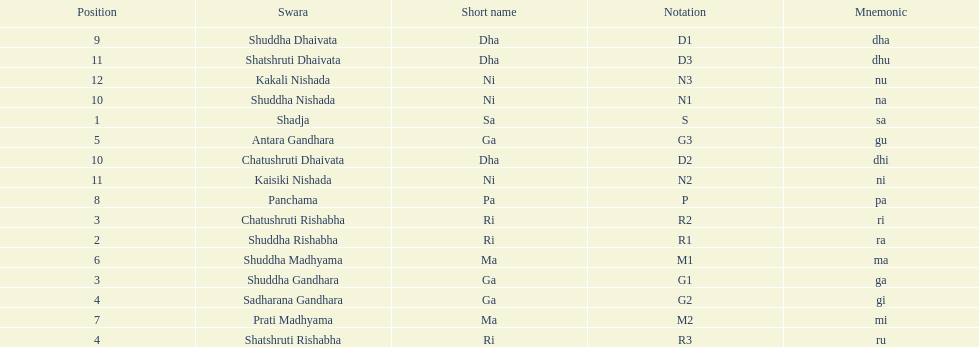What is the name of the swara that comes after panchama? Shuddha Dhaivata. 